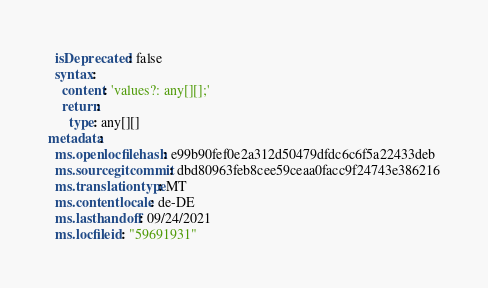Convert code to text. <code><loc_0><loc_0><loc_500><loc_500><_YAML_>  isDeprecated: false
  syntax:
    content: 'values?: any[][];'
    return:
      type: any[][]
metadata:
  ms.openlocfilehash: e99b90fef0e2a312d50479dfdc6c6f5a22433deb
  ms.sourcegitcommit: dbd80963feb8cee59ceaa0facc9f24743e386216
  ms.translationtype: MT
  ms.contentlocale: de-DE
  ms.lasthandoff: 09/24/2021
  ms.locfileid: "59691931"
</code> 